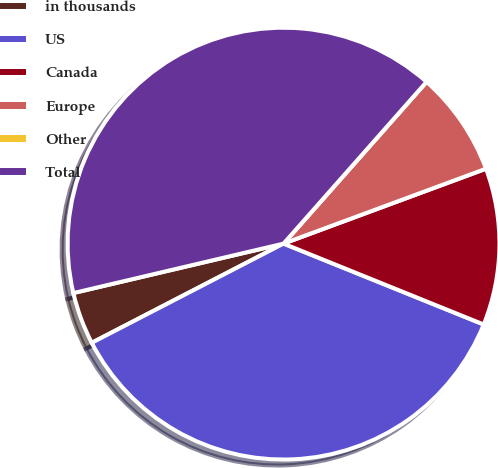Convert chart to OTSL. <chart><loc_0><loc_0><loc_500><loc_500><pie_chart><fcel>in thousands<fcel>US<fcel>Canada<fcel>Europe<fcel>Other<fcel>Total<nl><fcel>3.92%<fcel>36.29%<fcel>11.75%<fcel>7.84%<fcel>0.0%<fcel>40.2%<nl></chart> 